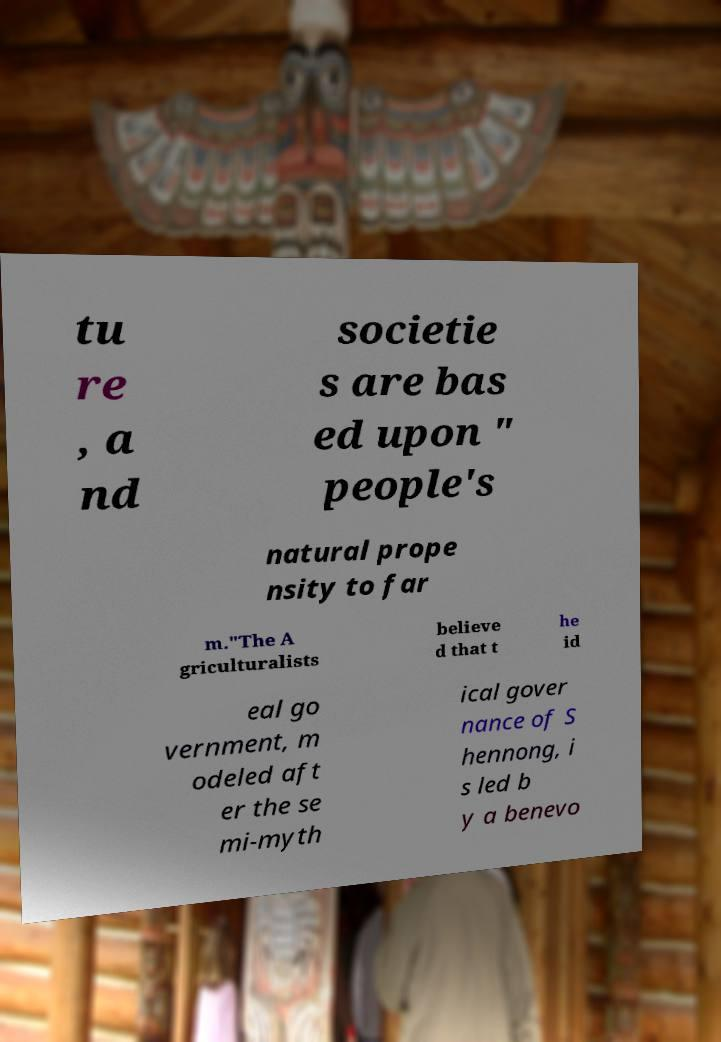Please identify and transcribe the text found in this image. tu re , a nd societie s are bas ed upon " people's natural prope nsity to far m."The A griculturalists believe d that t he id eal go vernment, m odeled aft er the se mi-myth ical gover nance of S hennong, i s led b y a benevo 